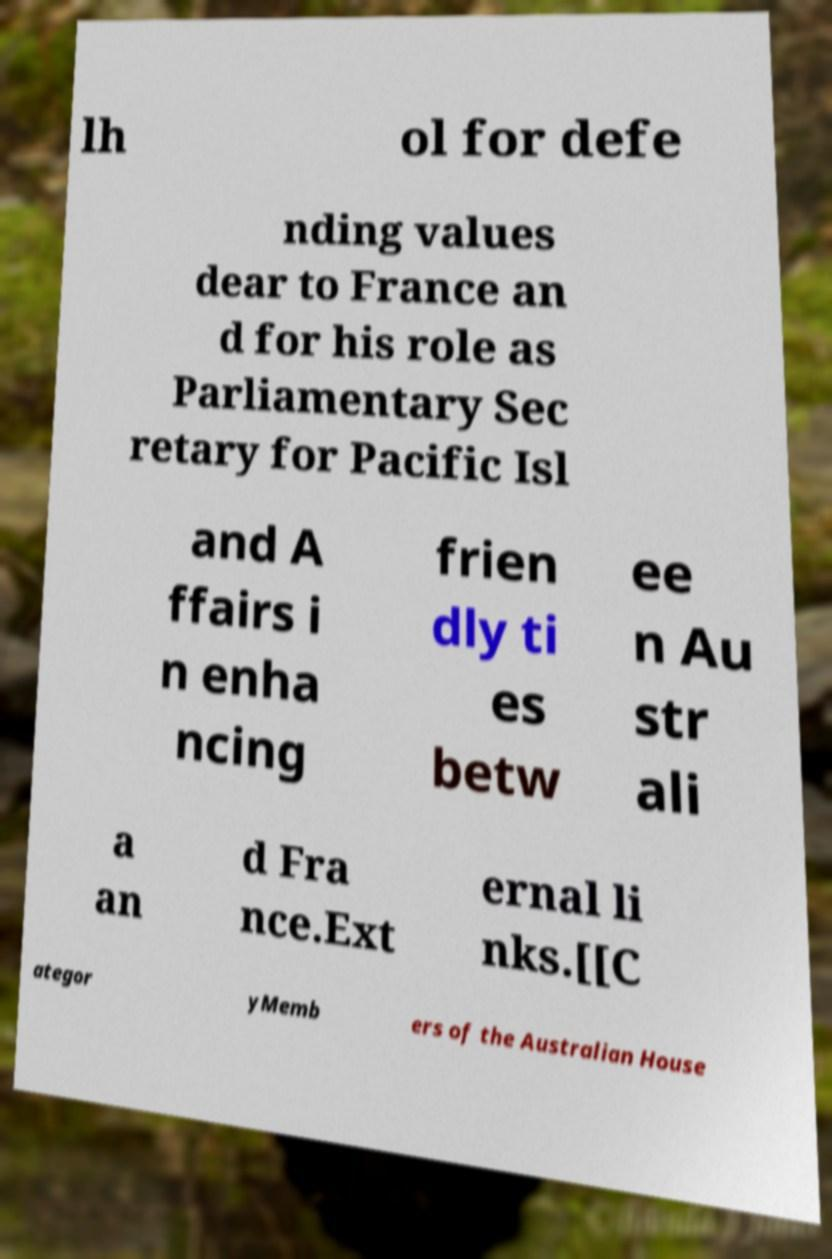Please read and relay the text visible in this image. What does it say? lh ol for defe nding values dear to France an d for his role as Parliamentary Sec retary for Pacific Isl and A ffairs i n enha ncing frien dly ti es betw ee n Au str ali a an d Fra nce.Ext ernal li nks.[[C ategor yMemb ers of the Australian House 